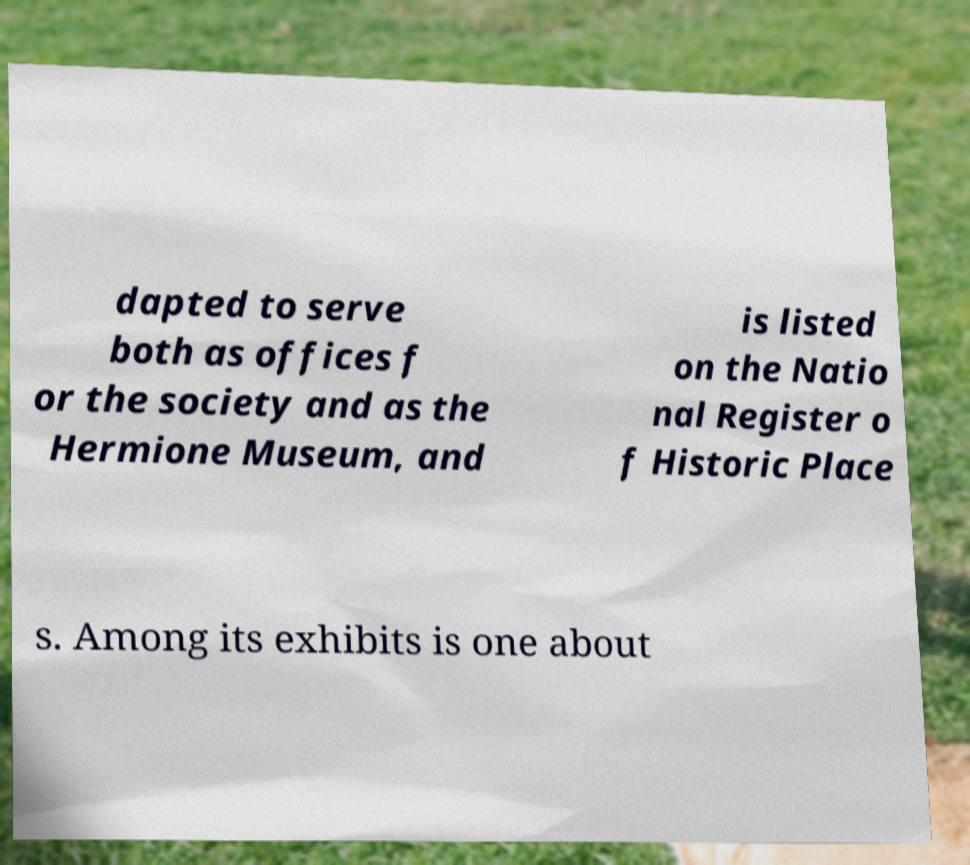For documentation purposes, I need the text within this image transcribed. Could you provide that? dapted to serve both as offices f or the society and as the Hermione Museum, and is listed on the Natio nal Register o f Historic Place s. Among its exhibits is one about 